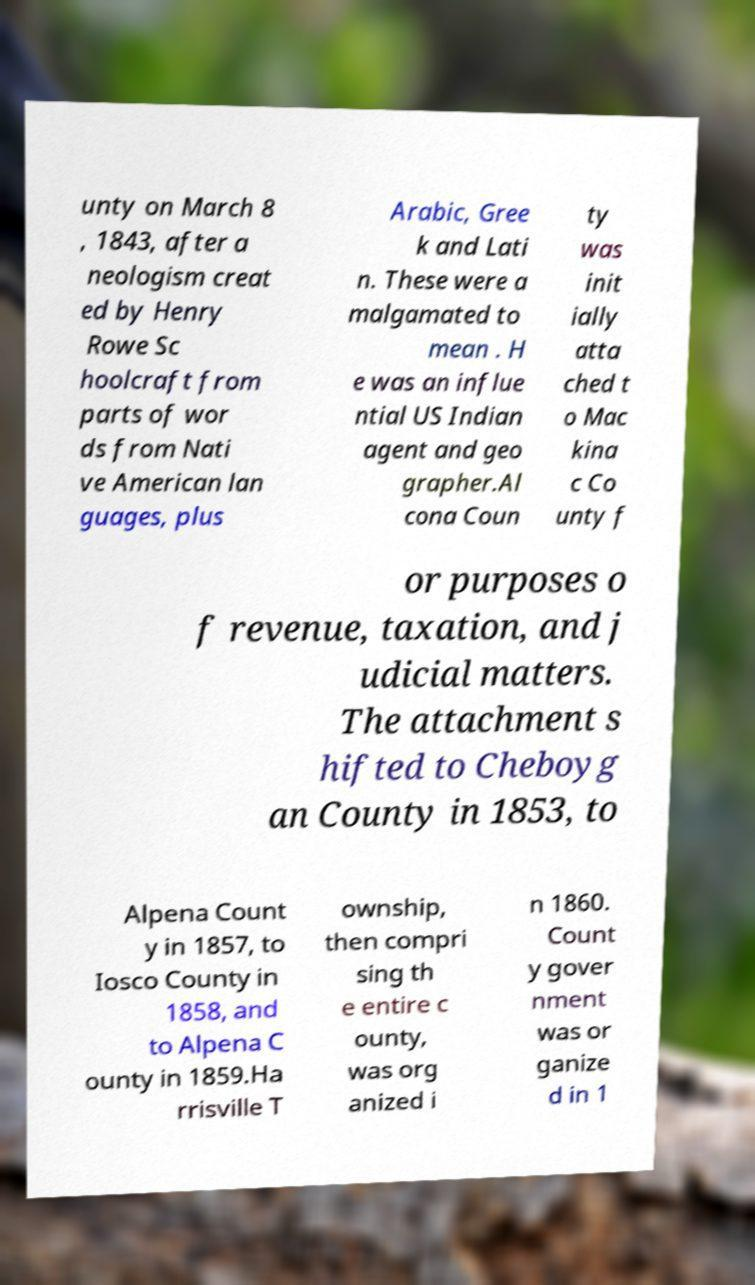Can you accurately transcribe the text from the provided image for me? unty on March 8 , 1843, after a neologism creat ed by Henry Rowe Sc hoolcraft from parts of wor ds from Nati ve American lan guages, plus Arabic, Gree k and Lati n. These were a malgamated to mean . H e was an influe ntial US Indian agent and geo grapher.Al cona Coun ty was init ially atta ched t o Mac kina c Co unty f or purposes o f revenue, taxation, and j udicial matters. The attachment s hifted to Cheboyg an County in 1853, to Alpena Count y in 1857, to Iosco County in 1858, and to Alpena C ounty in 1859.Ha rrisville T ownship, then compri sing th e entire c ounty, was org anized i n 1860. Count y gover nment was or ganize d in 1 